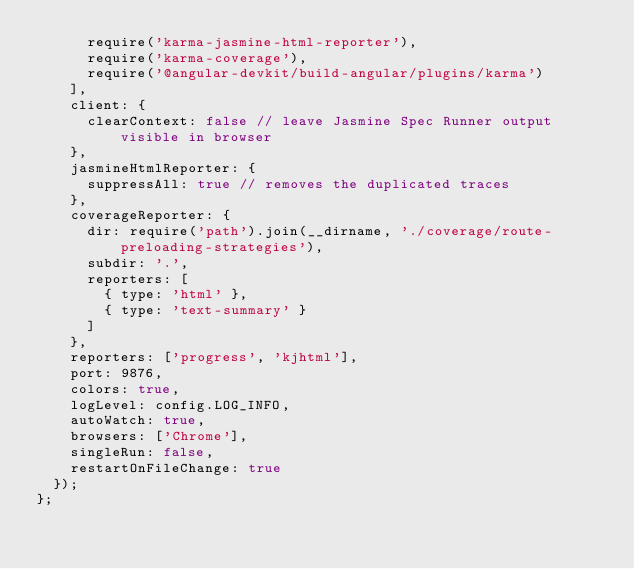<code> <loc_0><loc_0><loc_500><loc_500><_JavaScript_>      require('karma-jasmine-html-reporter'),
      require('karma-coverage'),
      require('@angular-devkit/build-angular/plugins/karma')
    ],
    client: {
      clearContext: false // leave Jasmine Spec Runner output visible in browser
    },
    jasmineHtmlReporter: {
      suppressAll: true // removes the duplicated traces
    },
    coverageReporter: {
      dir: require('path').join(__dirname, './coverage/route-preloading-strategies'),
      subdir: '.',
      reporters: [
        { type: 'html' },
        { type: 'text-summary' }
      ]
    },
    reporters: ['progress', 'kjhtml'],
    port: 9876,
    colors: true,
    logLevel: config.LOG_INFO,
    autoWatch: true,
    browsers: ['Chrome'],
    singleRun: false,
    restartOnFileChange: true
  });
};
</code> 